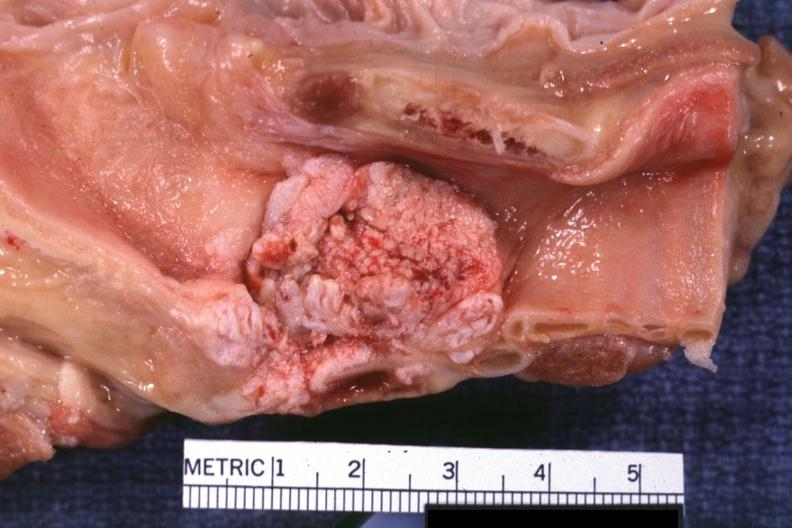does this image show large fungating lesion very good photo?
Answer the question using a single word or phrase. Yes 